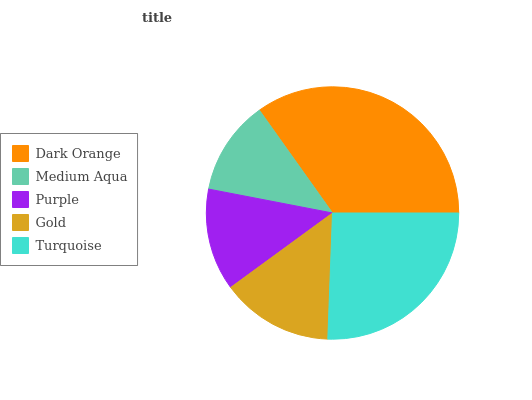Is Medium Aqua the minimum?
Answer yes or no. Yes. Is Dark Orange the maximum?
Answer yes or no. Yes. Is Purple the minimum?
Answer yes or no. No. Is Purple the maximum?
Answer yes or no. No. Is Purple greater than Medium Aqua?
Answer yes or no. Yes. Is Medium Aqua less than Purple?
Answer yes or no. Yes. Is Medium Aqua greater than Purple?
Answer yes or no. No. Is Purple less than Medium Aqua?
Answer yes or no. No. Is Gold the high median?
Answer yes or no. Yes. Is Gold the low median?
Answer yes or no. Yes. Is Turquoise the high median?
Answer yes or no. No. Is Medium Aqua the low median?
Answer yes or no. No. 